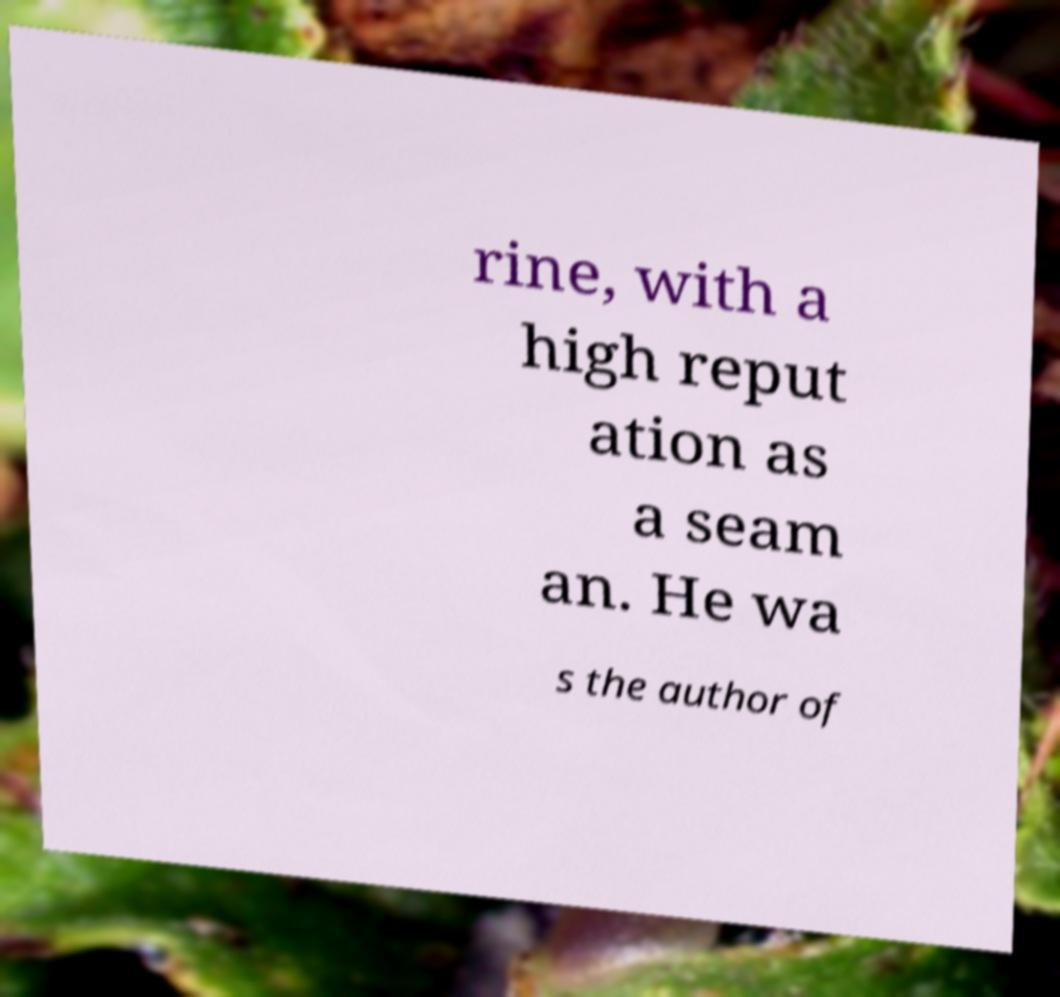Please read and relay the text visible in this image. What does it say? rine, with a high reput ation as a seam an. He wa s the author of 